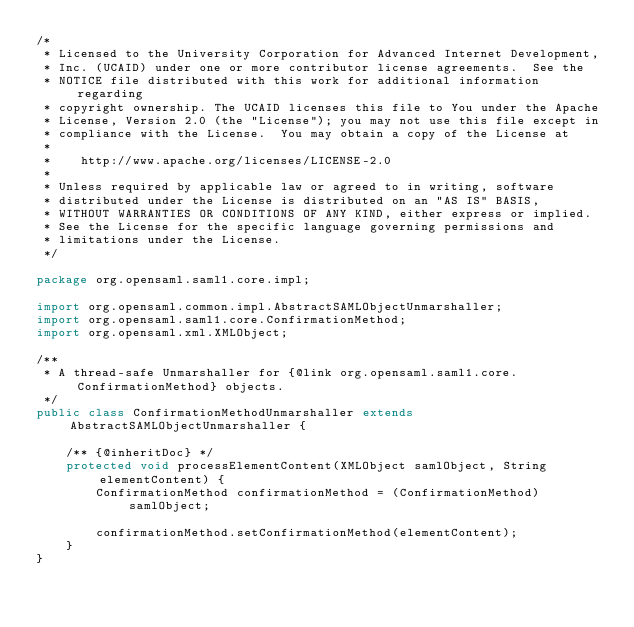Convert code to text. <code><loc_0><loc_0><loc_500><loc_500><_Java_>/*
 * Licensed to the University Corporation for Advanced Internet Development, 
 * Inc. (UCAID) under one or more contributor license agreements.  See the 
 * NOTICE file distributed with this work for additional information regarding
 * copyright ownership. The UCAID licenses this file to You under the Apache 
 * License, Version 2.0 (the "License"); you may not use this file except in 
 * compliance with the License.  You may obtain a copy of the License at
 *
 *    http://www.apache.org/licenses/LICENSE-2.0
 *
 * Unless required by applicable law or agreed to in writing, software
 * distributed under the License is distributed on an "AS IS" BASIS,
 * WITHOUT WARRANTIES OR CONDITIONS OF ANY KIND, either express or implied.
 * See the License for the specific language governing permissions and
 * limitations under the License.
 */

package org.opensaml.saml1.core.impl;

import org.opensaml.common.impl.AbstractSAMLObjectUnmarshaller;
import org.opensaml.saml1.core.ConfirmationMethod;
import org.opensaml.xml.XMLObject;

/**
 * A thread-safe Unmarshaller for {@link org.opensaml.saml1.core.ConfirmationMethod} objects.
 */
public class ConfirmationMethodUnmarshaller extends AbstractSAMLObjectUnmarshaller {

    /** {@inheritDoc} */
    protected void processElementContent(XMLObject samlObject, String elementContent) {
        ConfirmationMethod confirmationMethod = (ConfirmationMethod) samlObject;

        confirmationMethod.setConfirmationMethod(elementContent);
    }
}</code> 